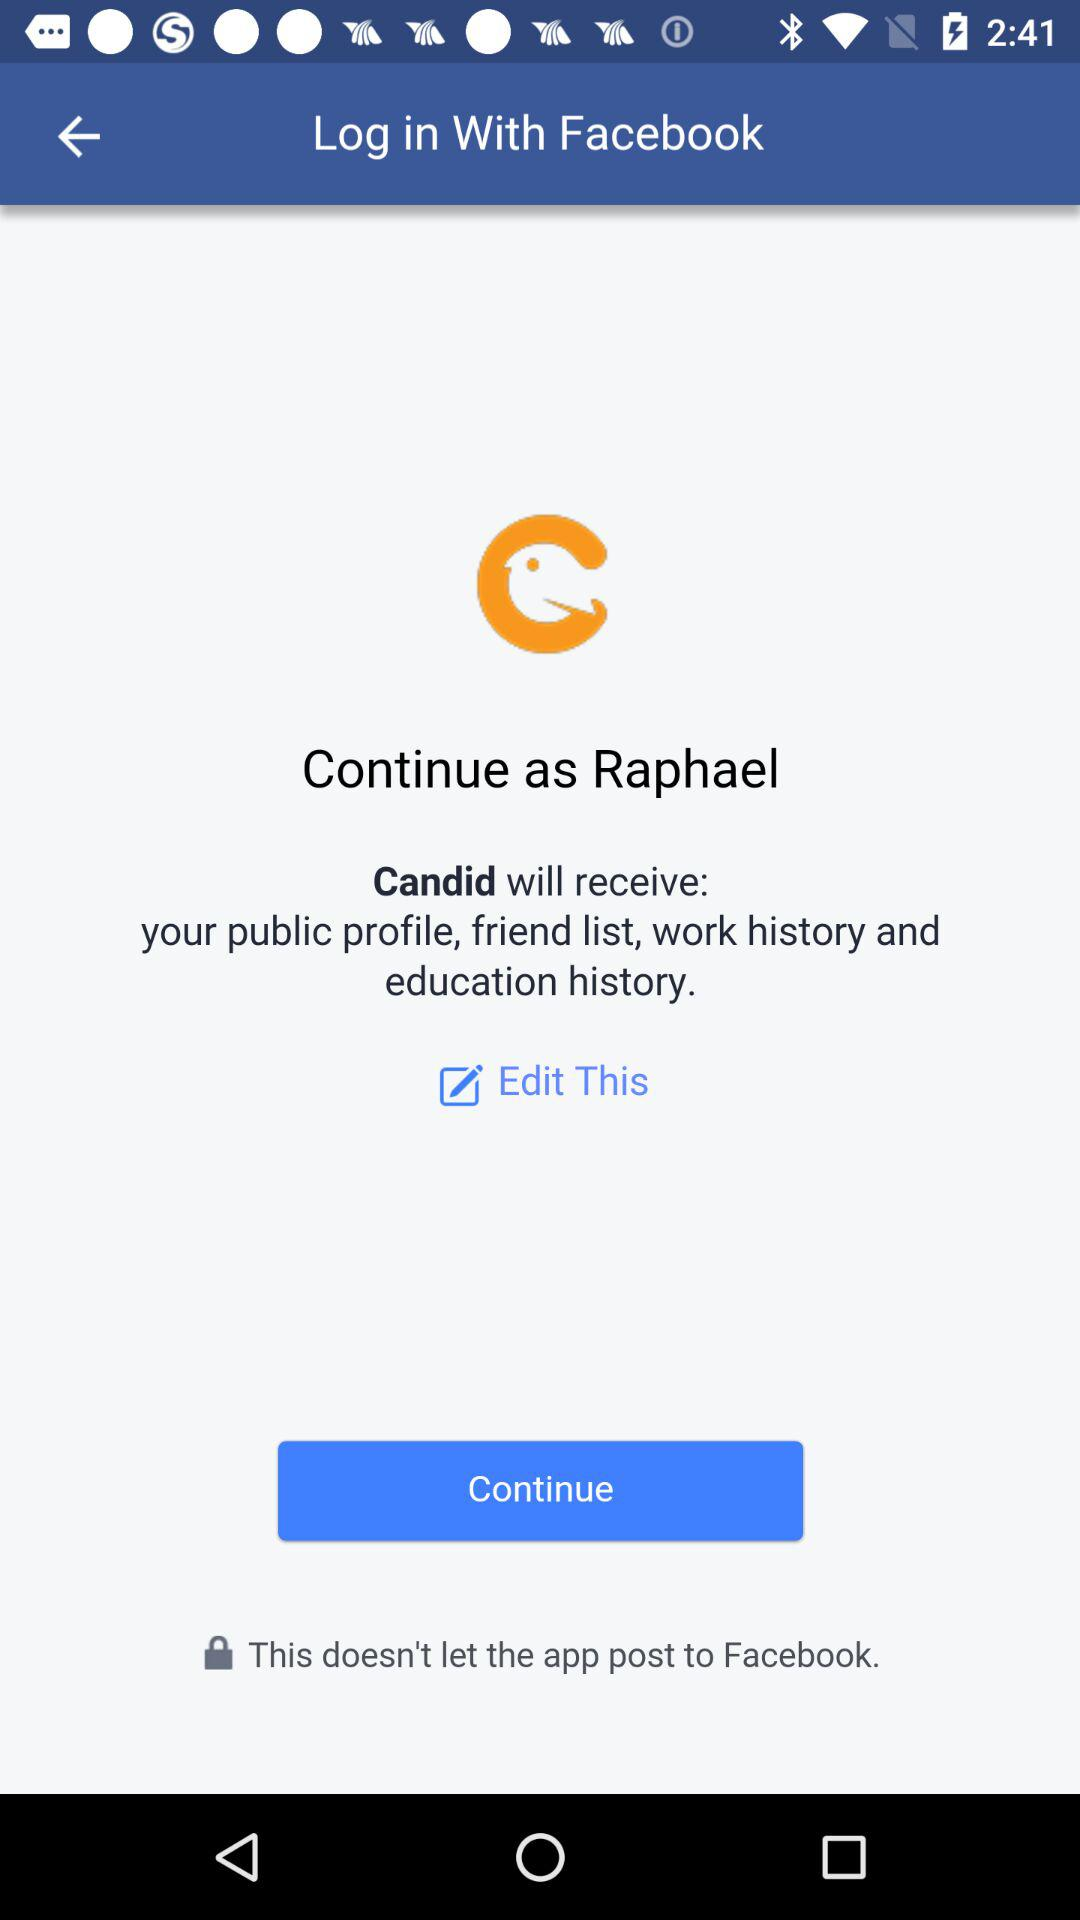What is the name of the user? The name of the user is Raphael. 